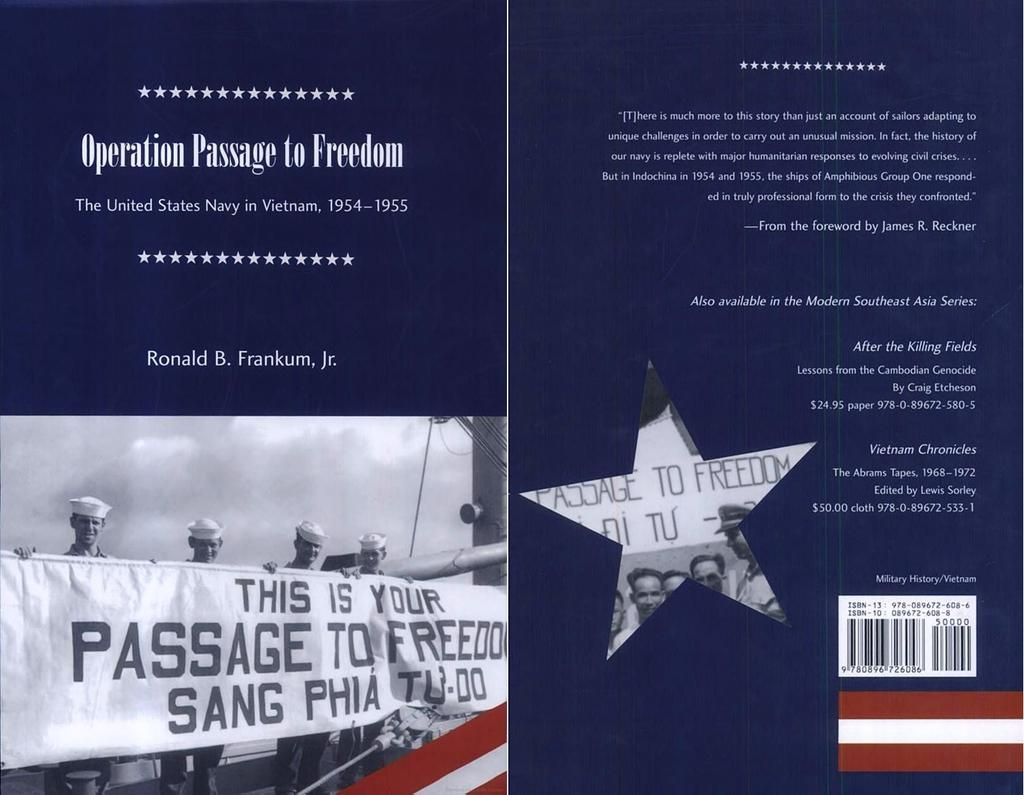<image>
Describe the image concisely. a pamphlet by the united states navy about viet nam 